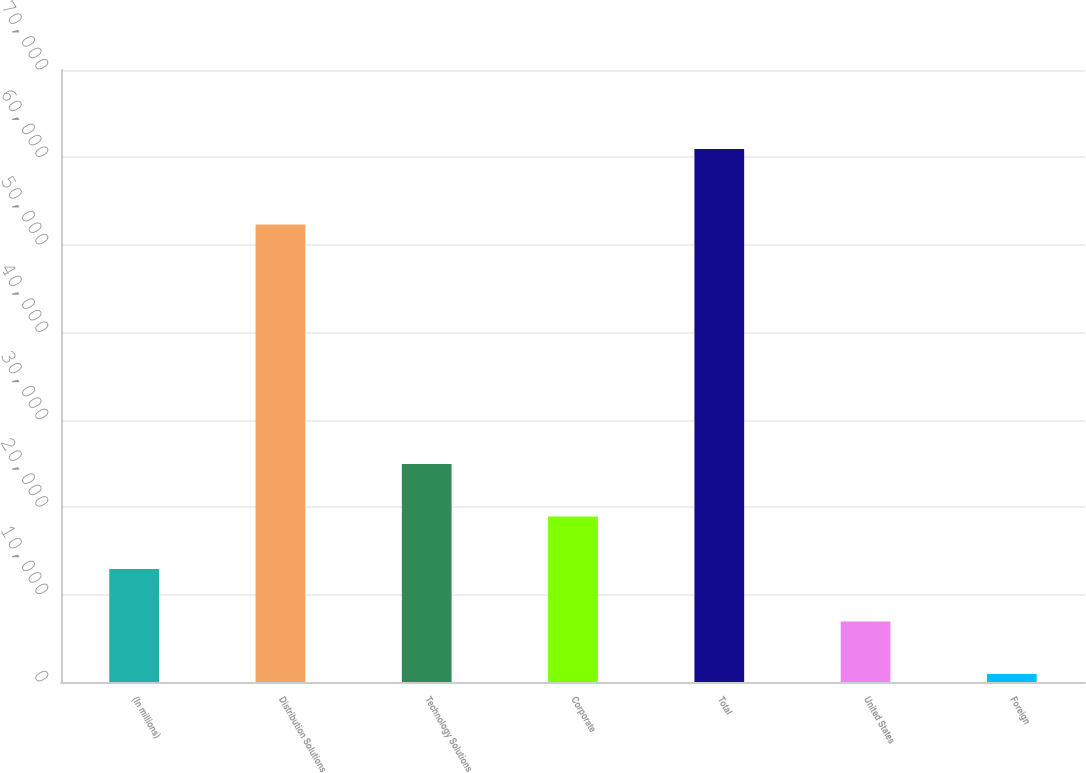<chart> <loc_0><loc_0><loc_500><loc_500><bar_chart><fcel>(In millions)<fcel>Distribution Solutions<fcel>Technology Solutions<fcel>Corporate<fcel>Total<fcel>United States<fcel>Foreign<nl><fcel>12921<fcel>52322<fcel>24933<fcel>18927<fcel>60969<fcel>6915<fcel>909<nl></chart> 